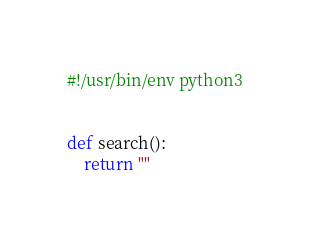<code> <loc_0><loc_0><loc_500><loc_500><_Python_>#!/usr/bin/env python3


def search():
    return ""
</code> 